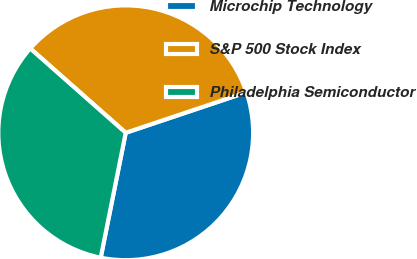Convert chart. <chart><loc_0><loc_0><loc_500><loc_500><pie_chart><fcel>Microchip Technology<fcel>S&P 500 Stock Index<fcel>Philadelphia Semiconductor<nl><fcel>33.3%<fcel>33.33%<fcel>33.37%<nl></chart> 